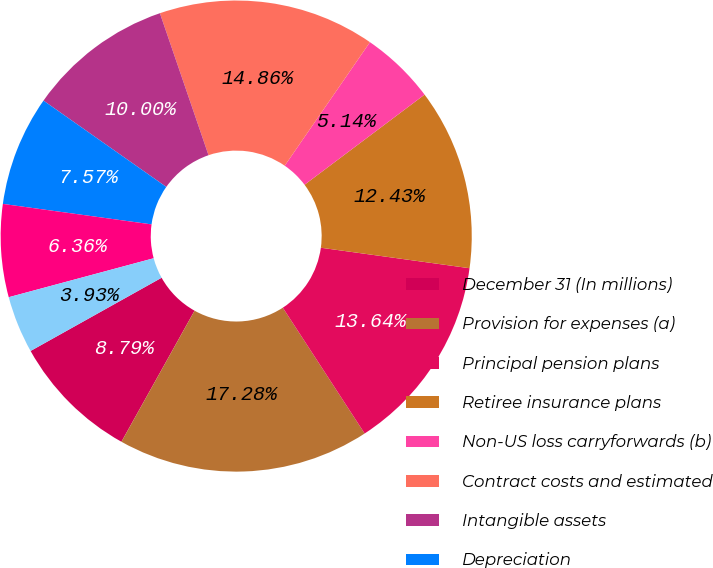<chart> <loc_0><loc_0><loc_500><loc_500><pie_chart><fcel>December 31 (In millions)<fcel>Provision for expenses (a)<fcel>Principal pension plans<fcel>Retiree insurance plans<fcel>Non-US loss carryforwards (b)<fcel>Contract costs and estimated<fcel>Intangible assets<fcel>Depreciation<fcel>Investment in global<fcel>Other-net<nl><fcel>8.79%<fcel>17.28%<fcel>13.64%<fcel>12.43%<fcel>5.14%<fcel>14.86%<fcel>10.0%<fcel>7.57%<fcel>6.36%<fcel>3.93%<nl></chart> 